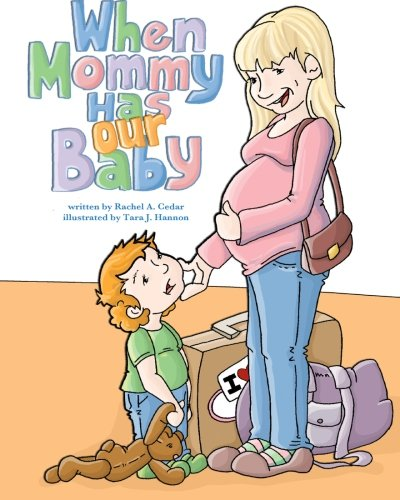Is this a child-care book? Yes, 'When Mommy Has Our Baby' is indeed a child-care book, aimed at helping children understand and cope with the arrival of a new sibling. 